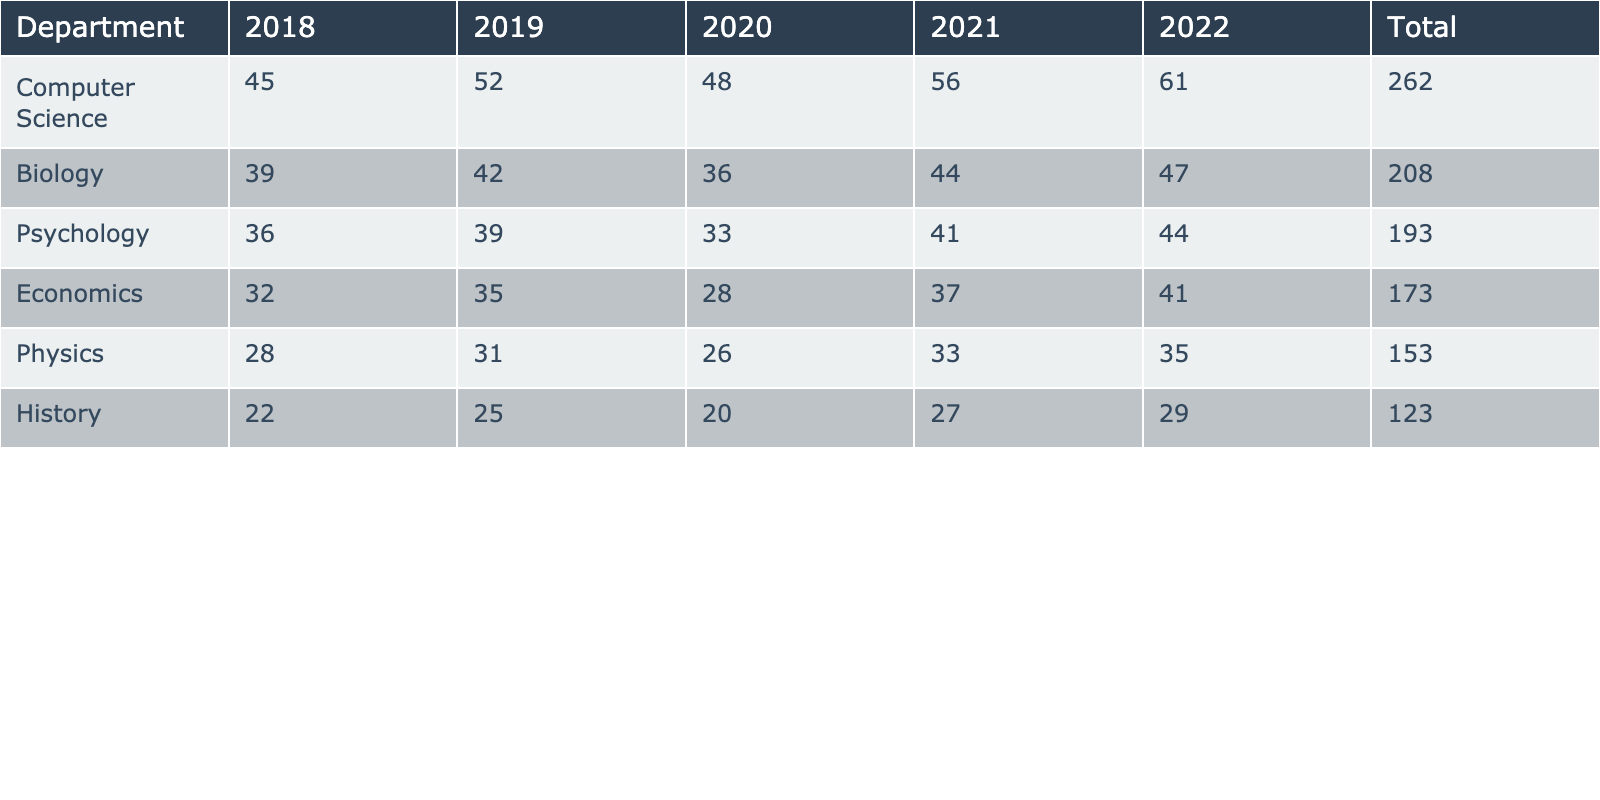What is the total number of publications for the Biology department in the last 5 years? To find the total for the Biology department, I add the publications for each year: 39 + 42 + 36 + 44 + 47 = 208.
Answer: 208 Which department had the highest number of publications in 2022? Looking at the column for 2022 in the table, Computer Science has 61 publications, which is the highest among all departments.
Answer: Computer Science What is the average number of publications for the Physics department over the last 5 years? I first sum the publications for Physics: 28 + 31 + 26 + 33 + 35 = 153. Then, I divide by 5 (years): 153 / 5 = 30.6.
Answer: 30.6 Which department showed a consistent increase in publications from 2018 to 2022? By checking the yearly publications, I see that the Computer Science department increased each year: 45, 52, 48, 56, 61. All values show an upward trend.
Answer: Yes What is the total number of publications across all departments from 2018 to 2022? I need to sum the total publications for all the departments over the 5 years: (32 + 35 + 28 + 37 + 41) + (45 + 52 + 48 + 56 + 61) + (39 + 42 + 36 + 44 + 47) + (28 + 31 + 26 + 33 + 35) + (22 + 25 + 20 + 27 + 29) + (36 + 39 + 33 + 41 + 44) = 836.
Answer: 836 In which year did the Psychology department have its lowest publication output? Checking the Psychology publications, the values are: 36, 39, 33, 41, and 44. The lowest value is 33, which occurs in 2020.
Answer: 2020 What is the difference in total publications between the Economics and History departments? I first find the total publications: Economics = 32 + 35 + 28 + 37 + 41 = 173; History = 22 + 25 + 20 + 27 + 29 = 123. The difference is 173 - 123 = 50.
Answer: 50 Which department had the least total publications over the 5 years? By checking the total for each department, I see that History has the lowest total with 123 publications.
Answer: History Did the Computer Science department ever publish fewer publications than the Physics department in any year during the last 5 years? I compare the yearly publications: Computer Science had 45, 52, 48, 56, 61, while Physics had 28, 31, 26, 33, 35. Computer Science is always higher each year.
Answer: No What was the overall trend in publications for the Biology department over the last 5 years? Looking at the yearly publications for Biology (39, 42, 36, 44, 47), there was an initial increase, a drop in 2020, but then it rose again in the following years. The overall trend is somewhat positive with fluctuations.
Answer: Fluctuating upward trend 